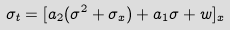Convert formula to latex. <formula><loc_0><loc_0><loc_500><loc_500>\sigma _ { t } = [ a _ { 2 } ( \sigma ^ { 2 } + \sigma _ { x } ) + a _ { 1 } \sigma + w ] _ { x }</formula> 